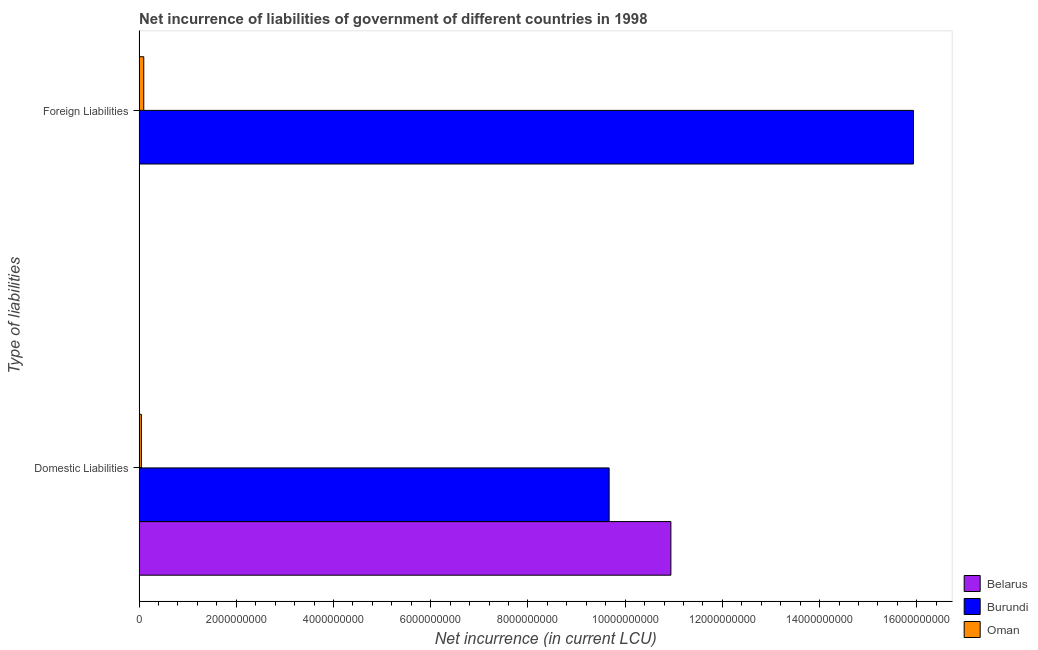Are the number of bars per tick equal to the number of legend labels?
Your answer should be very brief. No. Are the number of bars on each tick of the Y-axis equal?
Ensure brevity in your answer.  No. What is the label of the 2nd group of bars from the top?
Your answer should be compact. Domestic Liabilities. What is the net incurrence of foreign liabilities in Belarus?
Your answer should be compact. 0. Across all countries, what is the maximum net incurrence of foreign liabilities?
Keep it short and to the point. 1.59e+1. Across all countries, what is the minimum net incurrence of domestic liabilities?
Offer a terse response. 4.66e+07. In which country was the net incurrence of foreign liabilities maximum?
Your response must be concise. Burundi. What is the total net incurrence of domestic liabilities in the graph?
Make the answer very short. 2.07e+1. What is the difference between the net incurrence of domestic liabilities in Oman and that in Burundi?
Offer a very short reply. -9.62e+09. What is the difference between the net incurrence of foreign liabilities in Oman and the net incurrence of domestic liabilities in Belarus?
Make the answer very short. -1.08e+1. What is the average net incurrence of domestic liabilities per country?
Ensure brevity in your answer.  6.89e+09. What is the difference between the net incurrence of domestic liabilities and net incurrence of foreign liabilities in Burundi?
Provide a succinct answer. -6.26e+09. What is the ratio of the net incurrence of domestic liabilities in Burundi to that in Oman?
Provide a succinct answer. 207.51. Are the values on the major ticks of X-axis written in scientific E-notation?
Your response must be concise. No. What is the title of the graph?
Your answer should be very brief. Net incurrence of liabilities of government of different countries in 1998. What is the label or title of the X-axis?
Keep it short and to the point. Net incurrence (in current LCU). What is the label or title of the Y-axis?
Provide a short and direct response. Type of liabilities. What is the Net incurrence (in current LCU) of Belarus in Domestic Liabilities?
Your response must be concise. 1.09e+1. What is the Net incurrence (in current LCU) of Burundi in Domestic Liabilities?
Give a very brief answer. 9.67e+09. What is the Net incurrence (in current LCU) in Oman in Domestic Liabilities?
Ensure brevity in your answer.  4.66e+07. What is the Net incurrence (in current LCU) of Belarus in Foreign Liabilities?
Your answer should be very brief. 0. What is the Net incurrence (in current LCU) of Burundi in Foreign Liabilities?
Provide a succinct answer. 1.59e+1. What is the Net incurrence (in current LCU) in Oman in Foreign Liabilities?
Keep it short and to the point. 9.59e+07. Across all Type of liabilities, what is the maximum Net incurrence (in current LCU) in Belarus?
Offer a very short reply. 1.09e+1. Across all Type of liabilities, what is the maximum Net incurrence (in current LCU) of Burundi?
Provide a succinct answer. 1.59e+1. Across all Type of liabilities, what is the maximum Net incurrence (in current LCU) of Oman?
Your answer should be compact. 9.59e+07. Across all Type of liabilities, what is the minimum Net incurrence (in current LCU) of Belarus?
Keep it short and to the point. 0. Across all Type of liabilities, what is the minimum Net incurrence (in current LCU) in Burundi?
Provide a succinct answer. 9.67e+09. Across all Type of liabilities, what is the minimum Net incurrence (in current LCU) of Oman?
Keep it short and to the point. 4.66e+07. What is the total Net incurrence (in current LCU) in Belarus in the graph?
Provide a short and direct response. 1.09e+1. What is the total Net incurrence (in current LCU) in Burundi in the graph?
Keep it short and to the point. 2.56e+1. What is the total Net incurrence (in current LCU) of Oman in the graph?
Provide a succinct answer. 1.42e+08. What is the difference between the Net incurrence (in current LCU) of Burundi in Domestic Liabilities and that in Foreign Liabilities?
Your answer should be compact. -6.26e+09. What is the difference between the Net incurrence (in current LCU) in Oman in Domestic Liabilities and that in Foreign Liabilities?
Make the answer very short. -4.93e+07. What is the difference between the Net incurrence (in current LCU) of Belarus in Domestic Liabilities and the Net incurrence (in current LCU) of Burundi in Foreign Liabilities?
Offer a very short reply. -4.99e+09. What is the difference between the Net incurrence (in current LCU) in Belarus in Domestic Liabilities and the Net incurrence (in current LCU) in Oman in Foreign Liabilities?
Give a very brief answer. 1.08e+1. What is the difference between the Net incurrence (in current LCU) in Burundi in Domestic Liabilities and the Net incurrence (in current LCU) in Oman in Foreign Liabilities?
Provide a short and direct response. 9.57e+09. What is the average Net incurrence (in current LCU) of Belarus per Type of liabilities?
Keep it short and to the point. 5.47e+09. What is the average Net incurrence (in current LCU) of Burundi per Type of liabilities?
Provide a succinct answer. 1.28e+1. What is the average Net incurrence (in current LCU) in Oman per Type of liabilities?
Offer a very short reply. 7.12e+07. What is the difference between the Net incurrence (in current LCU) of Belarus and Net incurrence (in current LCU) of Burundi in Domestic Liabilities?
Ensure brevity in your answer.  1.27e+09. What is the difference between the Net incurrence (in current LCU) in Belarus and Net incurrence (in current LCU) in Oman in Domestic Liabilities?
Provide a succinct answer. 1.09e+1. What is the difference between the Net incurrence (in current LCU) in Burundi and Net incurrence (in current LCU) in Oman in Domestic Liabilities?
Your response must be concise. 9.62e+09. What is the difference between the Net incurrence (in current LCU) in Burundi and Net incurrence (in current LCU) in Oman in Foreign Liabilities?
Provide a succinct answer. 1.58e+1. What is the ratio of the Net incurrence (in current LCU) of Burundi in Domestic Liabilities to that in Foreign Liabilities?
Your answer should be compact. 0.61. What is the ratio of the Net incurrence (in current LCU) of Oman in Domestic Liabilities to that in Foreign Liabilities?
Make the answer very short. 0.49. What is the difference between the highest and the second highest Net incurrence (in current LCU) in Burundi?
Your answer should be very brief. 6.26e+09. What is the difference between the highest and the second highest Net incurrence (in current LCU) of Oman?
Ensure brevity in your answer.  4.93e+07. What is the difference between the highest and the lowest Net incurrence (in current LCU) of Belarus?
Give a very brief answer. 1.09e+1. What is the difference between the highest and the lowest Net incurrence (in current LCU) of Burundi?
Make the answer very short. 6.26e+09. What is the difference between the highest and the lowest Net incurrence (in current LCU) of Oman?
Keep it short and to the point. 4.93e+07. 